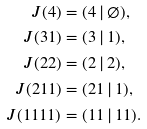<formula> <loc_0><loc_0><loc_500><loc_500>J ( 4 ) & = ( 4 \, | \, \varnothing ) , \\ J ( 3 1 ) & = ( 3 \, | \, 1 ) , \\ J ( 2 2 ) & = ( 2 \, | \, 2 ) , \\ J ( 2 1 1 ) & = ( 2 1 \, | \, 1 ) , \\ J ( 1 1 1 1 ) & = ( 1 1 \, | \, 1 1 ) .</formula> 